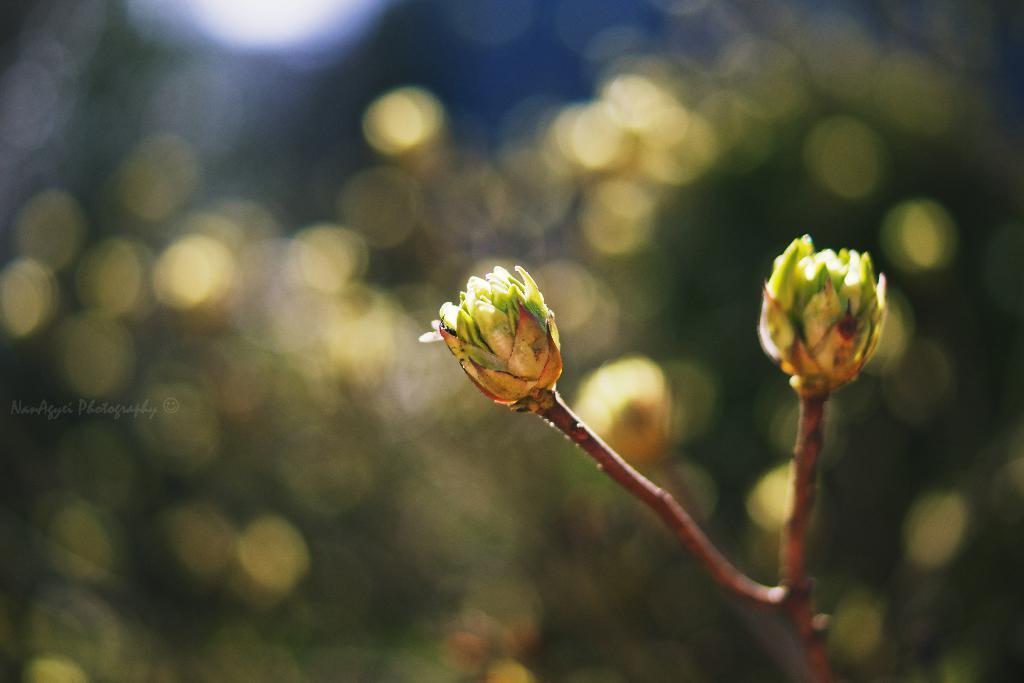Please provide a concise description of this image. In this picture there is a plant with buds towards the right. 